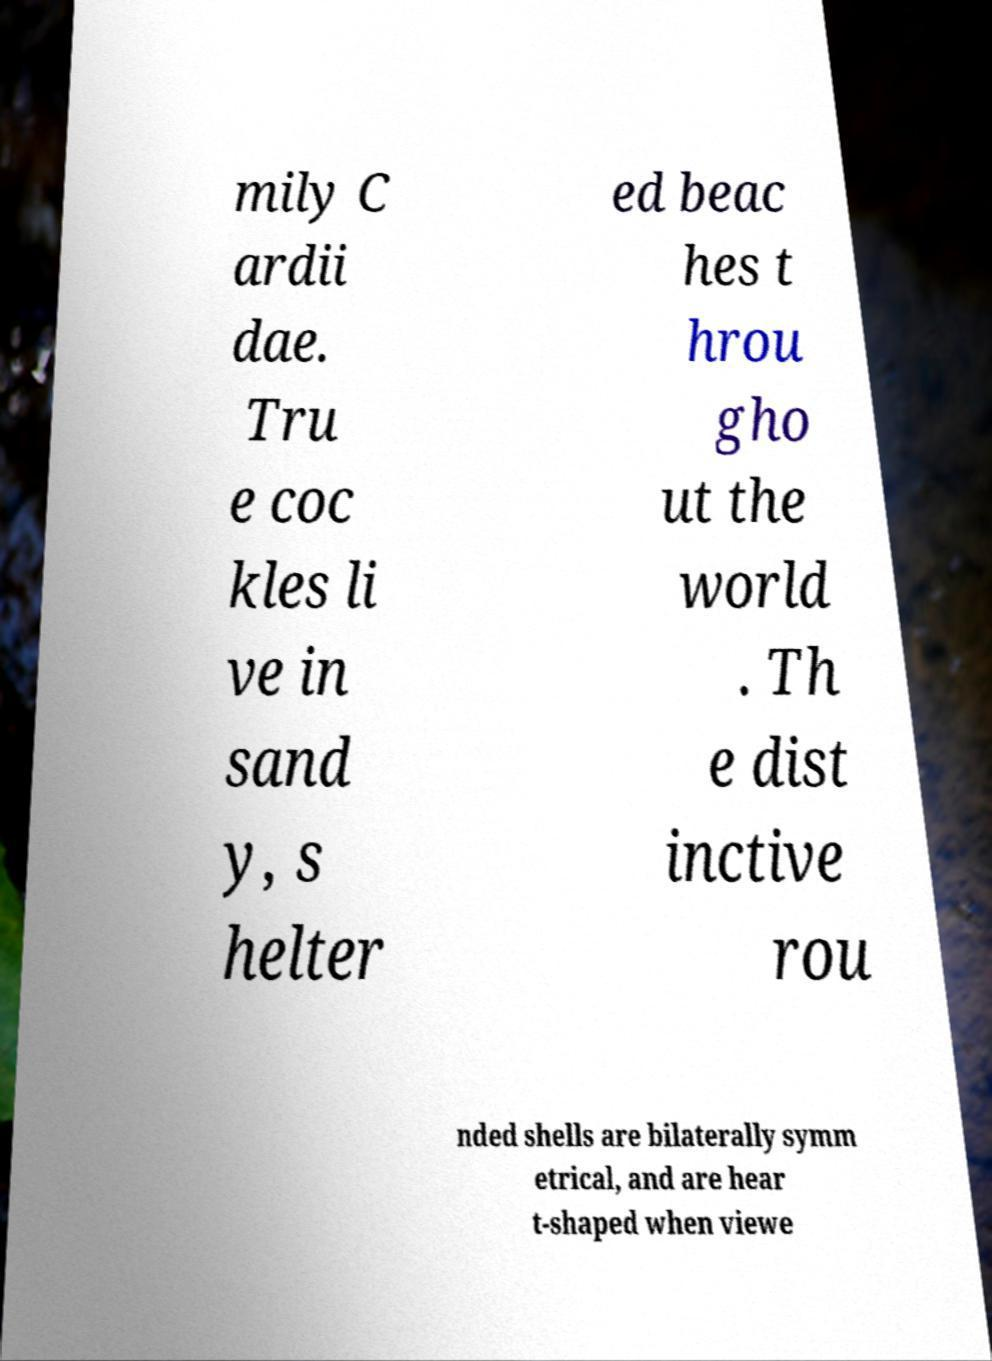Could you assist in decoding the text presented in this image and type it out clearly? mily C ardii dae. Tru e coc kles li ve in sand y, s helter ed beac hes t hrou gho ut the world . Th e dist inctive rou nded shells are bilaterally symm etrical, and are hear t-shaped when viewe 